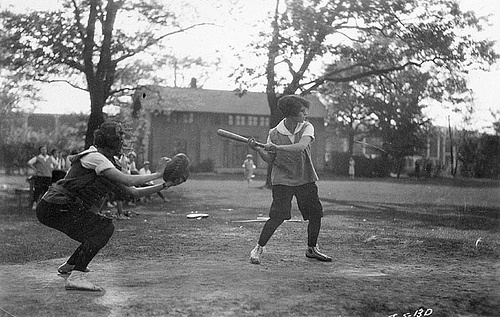Describe the objects in this image and their specific colors. I can see people in white, black, gray, darkgray, and lightgray tones, people in white, gray, black, darkgray, and lightgray tones, people in white, gray, black, darkgray, and lightgray tones, baseball glove in white, black, gray, darkgray, and lightgray tones, and baseball bat in white, gray, darkgray, lightgray, and black tones in this image. 